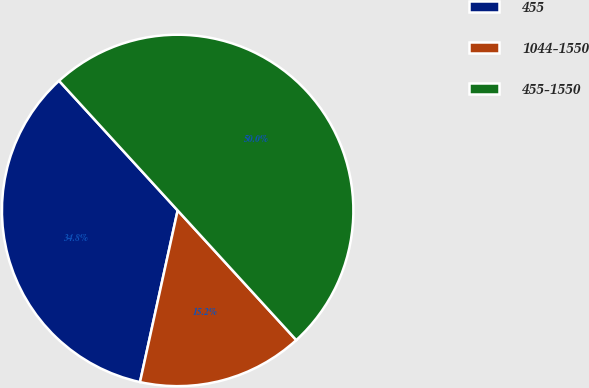Convert chart. <chart><loc_0><loc_0><loc_500><loc_500><pie_chart><fcel>455<fcel>1044-1550<fcel>455-1550<nl><fcel>34.77%<fcel>15.23%<fcel>50.0%<nl></chart> 